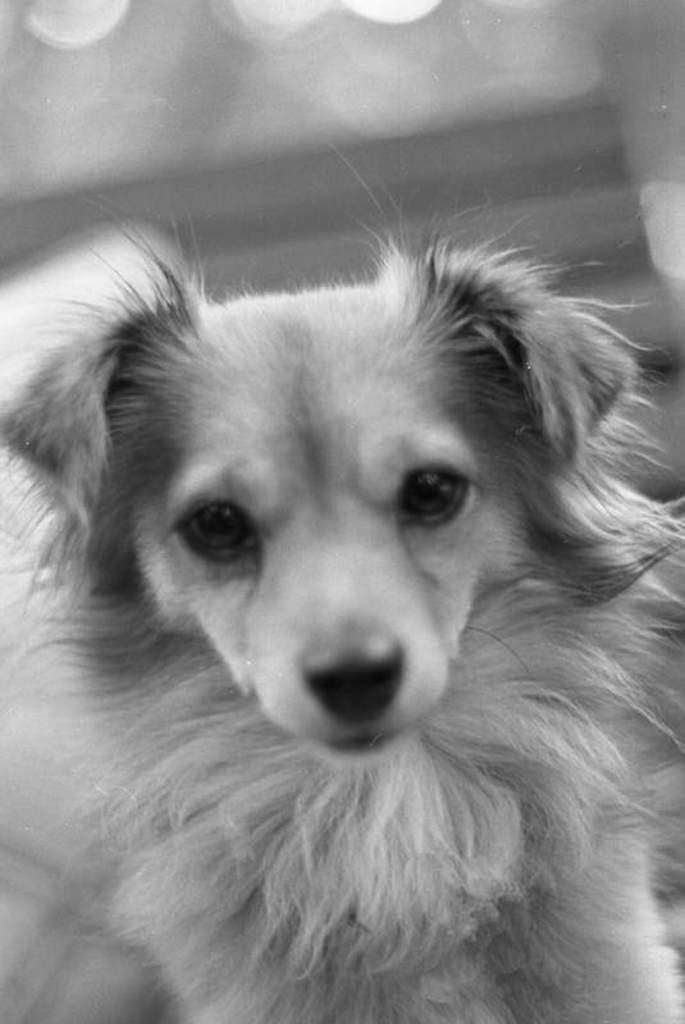What is the color scheme of the image? The image is black and white. What is the main subject of the image? There is a dog in the center of the image. What type of surprise can be seen in the image? There is no surprise present in the image; it features a dog in a black and white setting. Who is the queen in the image? There is no queen present in the image; it only features a dog. 